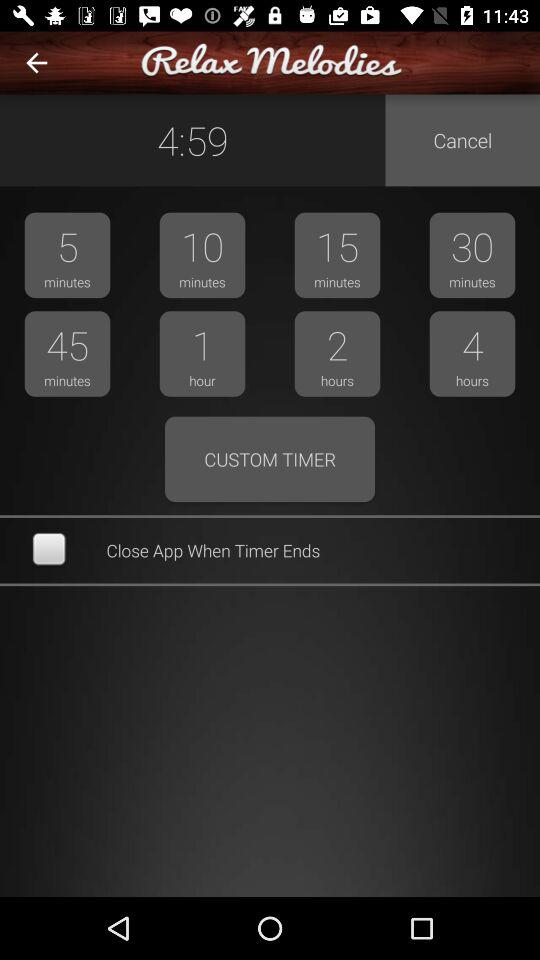What is the status of "Close App When Timer Ends"? The status of "Close App When Timer Ends" is "off". 